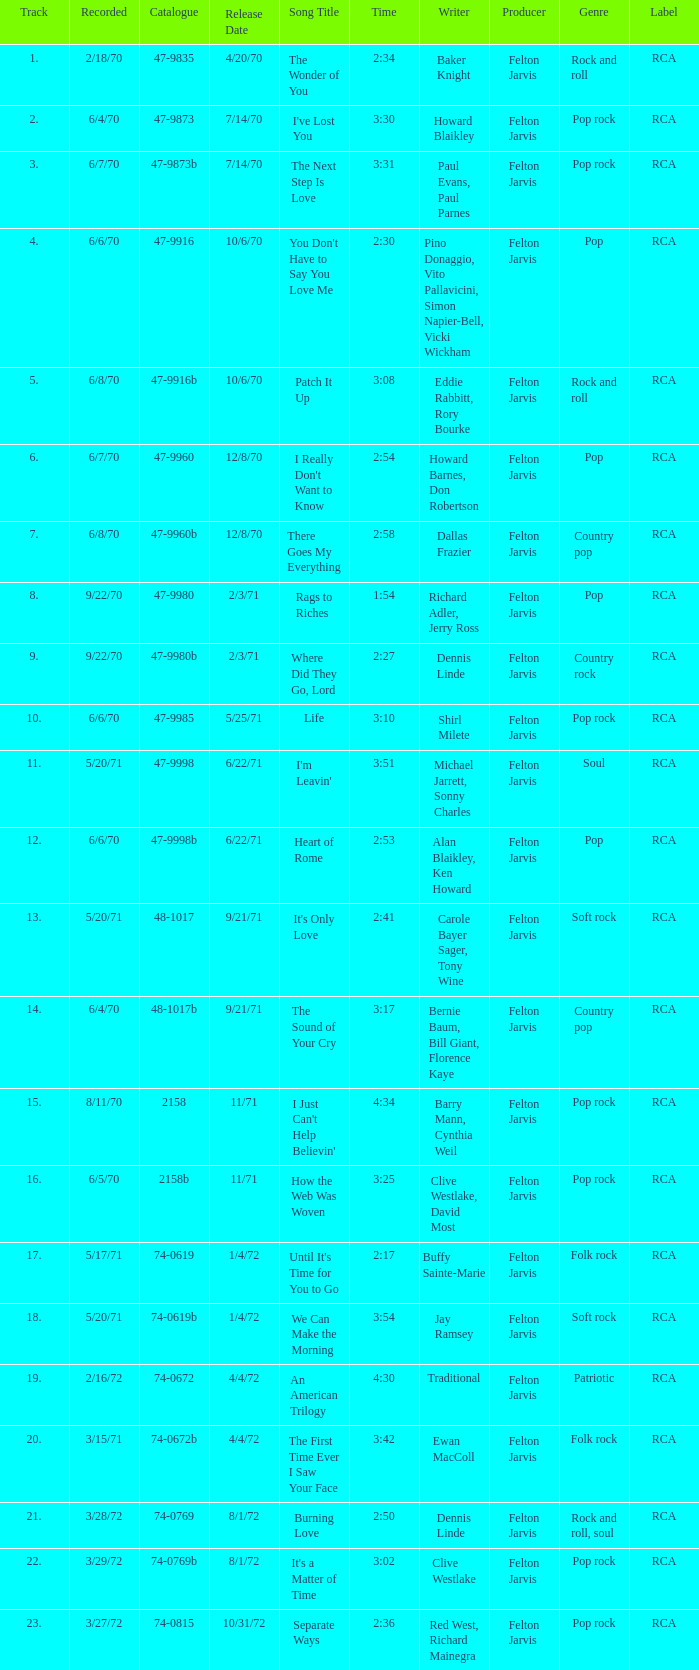What is Heart of Rome's catalogue number? 47-9998b. 